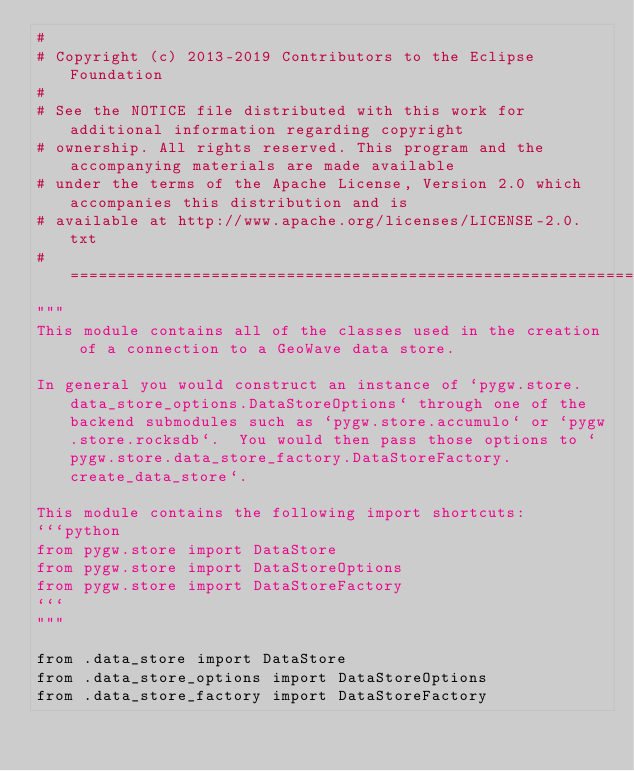Convert code to text. <code><loc_0><loc_0><loc_500><loc_500><_Python_>#
# Copyright (c) 2013-2019 Contributors to the Eclipse Foundation
#
# See the NOTICE file distributed with this work for additional information regarding copyright
# ownership. All rights reserved. This program and the accompanying materials are made available
# under the terms of the Apache License, Version 2.0 which accompanies this distribution and is
# available at http://www.apache.org/licenses/LICENSE-2.0.txt
#===============================================================================================
"""
This module contains all of the classes used in the creation of a connection to a GeoWave data store.

In general you would construct an instance of `pygw.store.data_store_options.DataStoreOptions` through one of the backend submodules such as `pygw.store.accumulo` or `pygw.store.rocksdb`.  You would then pass those options to `pygw.store.data_store_factory.DataStoreFactory.create_data_store`.

This module contains the following import shortcuts:
```python
from pygw.store import DataStore
from pygw.store import DataStoreOptions
from pygw.store import DataStoreFactory
```
"""

from .data_store import DataStore
from .data_store_options import DataStoreOptions
from .data_store_factory import DataStoreFactory
</code> 